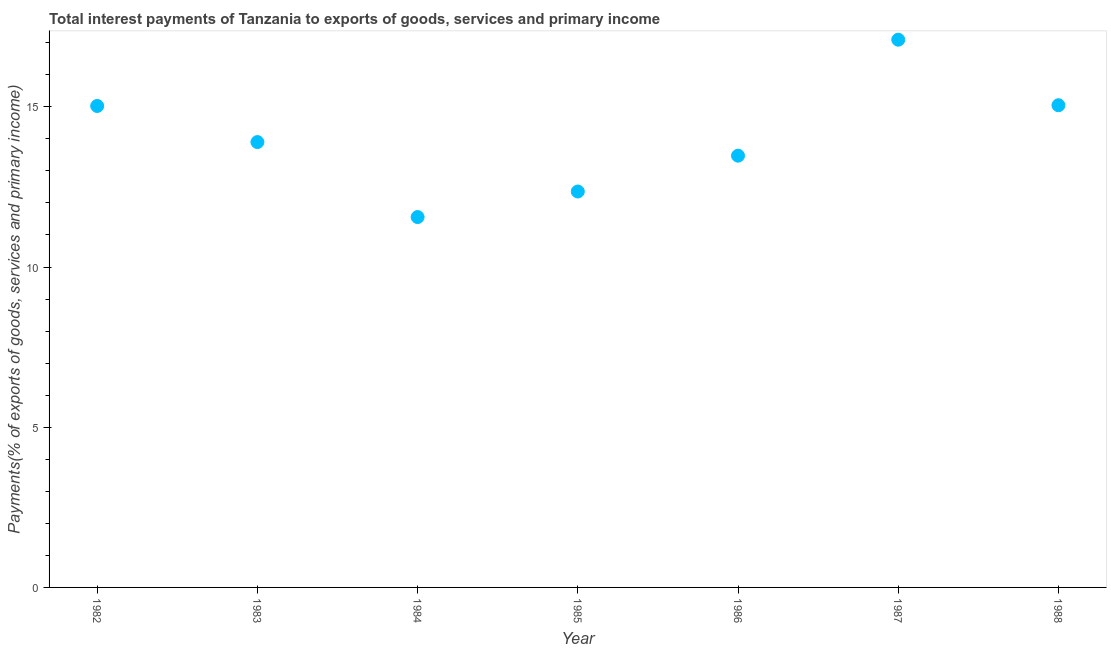What is the total interest payments on external debt in 1982?
Provide a succinct answer. 15.03. Across all years, what is the maximum total interest payments on external debt?
Your answer should be compact. 17.1. Across all years, what is the minimum total interest payments on external debt?
Your answer should be very brief. 11.56. What is the sum of the total interest payments on external debt?
Make the answer very short. 98.46. What is the difference between the total interest payments on external debt in 1985 and 1988?
Your answer should be compact. -2.69. What is the average total interest payments on external debt per year?
Make the answer very short. 14.07. What is the median total interest payments on external debt?
Offer a very short reply. 13.9. What is the ratio of the total interest payments on external debt in 1985 to that in 1987?
Provide a succinct answer. 0.72. What is the difference between the highest and the second highest total interest payments on external debt?
Your answer should be compact. 2.05. Is the sum of the total interest payments on external debt in 1985 and 1987 greater than the maximum total interest payments on external debt across all years?
Your response must be concise. Yes. What is the difference between the highest and the lowest total interest payments on external debt?
Offer a very short reply. 5.54. Does the total interest payments on external debt monotonically increase over the years?
Offer a very short reply. No. How many years are there in the graph?
Ensure brevity in your answer.  7. What is the difference between two consecutive major ticks on the Y-axis?
Keep it short and to the point. 5. Are the values on the major ticks of Y-axis written in scientific E-notation?
Ensure brevity in your answer.  No. Does the graph contain any zero values?
Give a very brief answer. No. Does the graph contain grids?
Your response must be concise. No. What is the title of the graph?
Provide a succinct answer. Total interest payments of Tanzania to exports of goods, services and primary income. What is the label or title of the Y-axis?
Your answer should be compact. Payments(% of exports of goods, services and primary income). What is the Payments(% of exports of goods, services and primary income) in 1982?
Your response must be concise. 15.03. What is the Payments(% of exports of goods, services and primary income) in 1983?
Your response must be concise. 13.9. What is the Payments(% of exports of goods, services and primary income) in 1984?
Your answer should be compact. 11.56. What is the Payments(% of exports of goods, services and primary income) in 1985?
Your answer should be very brief. 12.36. What is the Payments(% of exports of goods, services and primary income) in 1986?
Offer a very short reply. 13.48. What is the Payments(% of exports of goods, services and primary income) in 1987?
Make the answer very short. 17.1. What is the Payments(% of exports of goods, services and primary income) in 1988?
Provide a short and direct response. 15.05. What is the difference between the Payments(% of exports of goods, services and primary income) in 1982 and 1983?
Your answer should be compact. 1.13. What is the difference between the Payments(% of exports of goods, services and primary income) in 1982 and 1984?
Provide a succinct answer. 3.47. What is the difference between the Payments(% of exports of goods, services and primary income) in 1982 and 1985?
Your response must be concise. 2.67. What is the difference between the Payments(% of exports of goods, services and primary income) in 1982 and 1986?
Give a very brief answer. 1.55. What is the difference between the Payments(% of exports of goods, services and primary income) in 1982 and 1987?
Ensure brevity in your answer.  -2.07. What is the difference between the Payments(% of exports of goods, services and primary income) in 1982 and 1988?
Your answer should be compact. -0.02. What is the difference between the Payments(% of exports of goods, services and primary income) in 1983 and 1984?
Make the answer very short. 2.34. What is the difference between the Payments(% of exports of goods, services and primary income) in 1983 and 1985?
Your answer should be compact. 1.54. What is the difference between the Payments(% of exports of goods, services and primary income) in 1983 and 1986?
Offer a terse response. 0.42. What is the difference between the Payments(% of exports of goods, services and primary income) in 1983 and 1987?
Offer a very short reply. -3.2. What is the difference between the Payments(% of exports of goods, services and primary income) in 1983 and 1988?
Give a very brief answer. -1.15. What is the difference between the Payments(% of exports of goods, services and primary income) in 1984 and 1985?
Provide a short and direct response. -0.8. What is the difference between the Payments(% of exports of goods, services and primary income) in 1984 and 1986?
Ensure brevity in your answer.  -1.92. What is the difference between the Payments(% of exports of goods, services and primary income) in 1984 and 1987?
Offer a terse response. -5.54. What is the difference between the Payments(% of exports of goods, services and primary income) in 1984 and 1988?
Make the answer very short. -3.49. What is the difference between the Payments(% of exports of goods, services and primary income) in 1985 and 1986?
Your answer should be very brief. -1.12. What is the difference between the Payments(% of exports of goods, services and primary income) in 1985 and 1987?
Your response must be concise. -4.74. What is the difference between the Payments(% of exports of goods, services and primary income) in 1985 and 1988?
Ensure brevity in your answer.  -2.69. What is the difference between the Payments(% of exports of goods, services and primary income) in 1986 and 1987?
Provide a short and direct response. -3.62. What is the difference between the Payments(% of exports of goods, services and primary income) in 1986 and 1988?
Provide a short and direct response. -1.57. What is the difference between the Payments(% of exports of goods, services and primary income) in 1987 and 1988?
Provide a short and direct response. 2.05. What is the ratio of the Payments(% of exports of goods, services and primary income) in 1982 to that in 1983?
Your answer should be very brief. 1.08. What is the ratio of the Payments(% of exports of goods, services and primary income) in 1982 to that in 1984?
Give a very brief answer. 1.3. What is the ratio of the Payments(% of exports of goods, services and primary income) in 1982 to that in 1985?
Offer a very short reply. 1.22. What is the ratio of the Payments(% of exports of goods, services and primary income) in 1982 to that in 1986?
Ensure brevity in your answer.  1.11. What is the ratio of the Payments(% of exports of goods, services and primary income) in 1982 to that in 1987?
Provide a short and direct response. 0.88. What is the ratio of the Payments(% of exports of goods, services and primary income) in 1982 to that in 1988?
Make the answer very short. 1. What is the ratio of the Payments(% of exports of goods, services and primary income) in 1983 to that in 1984?
Your answer should be very brief. 1.2. What is the ratio of the Payments(% of exports of goods, services and primary income) in 1983 to that in 1986?
Provide a short and direct response. 1.03. What is the ratio of the Payments(% of exports of goods, services and primary income) in 1983 to that in 1987?
Offer a very short reply. 0.81. What is the ratio of the Payments(% of exports of goods, services and primary income) in 1983 to that in 1988?
Your response must be concise. 0.92. What is the ratio of the Payments(% of exports of goods, services and primary income) in 1984 to that in 1985?
Provide a short and direct response. 0.94. What is the ratio of the Payments(% of exports of goods, services and primary income) in 1984 to that in 1986?
Your answer should be very brief. 0.86. What is the ratio of the Payments(% of exports of goods, services and primary income) in 1984 to that in 1987?
Provide a succinct answer. 0.68. What is the ratio of the Payments(% of exports of goods, services and primary income) in 1984 to that in 1988?
Make the answer very short. 0.77. What is the ratio of the Payments(% of exports of goods, services and primary income) in 1985 to that in 1986?
Your answer should be compact. 0.92. What is the ratio of the Payments(% of exports of goods, services and primary income) in 1985 to that in 1987?
Ensure brevity in your answer.  0.72. What is the ratio of the Payments(% of exports of goods, services and primary income) in 1985 to that in 1988?
Offer a very short reply. 0.82. What is the ratio of the Payments(% of exports of goods, services and primary income) in 1986 to that in 1987?
Make the answer very short. 0.79. What is the ratio of the Payments(% of exports of goods, services and primary income) in 1986 to that in 1988?
Offer a very short reply. 0.9. What is the ratio of the Payments(% of exports of goods, services and primary income) in 1987 to that in 1988?
Your answer should be compact. 1.14. 